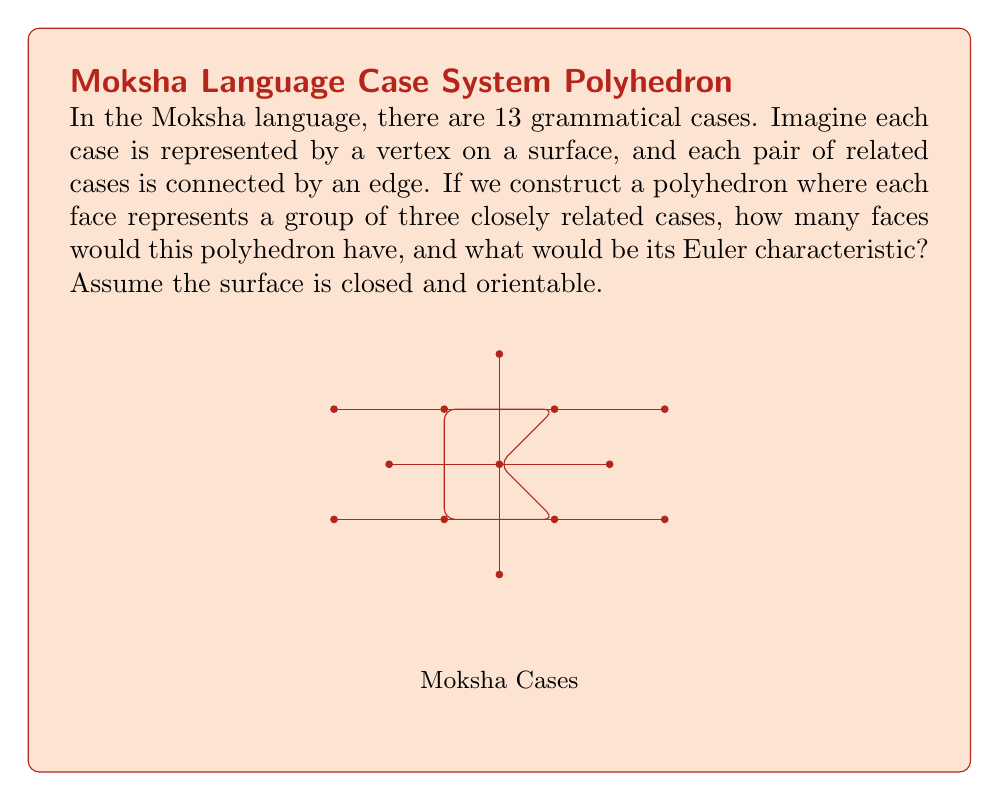What is the answer to this math problem? Let's approach this step-by-step:

1) We know that there are 13 vertices, representing the 13 grammatical cases in Moksha.

2) To calculate the number of faces and the Euler characteristic, we need to determine the number of edges. Let's assume that each vertex is connected to 4 other vertices on average (this is an assumption based on the typical connectivity in linguistic relationships).

3) The number of edges (E) would then be:
   $$ E = \frac{13 \times 4}{2} = 26 $$
   (We divide by 2 to avoid counting each edge twice)

4) Now, to find the number of faces (F), we can use the Euler characteristic formula:
   $$ \chi = V - E + F $$
   Where $\chi$ is the Euler characteristic, V is the number of vertices, E is the number of edges, and F is the number of faces.

5) For a closed, orientable surface, the Euler characteristic is related to the genus g by:
   $$ \chi = 2 - 2g $$

6) Assuming our surface is topologically equivalent to a sphere (g = 0), we have:
   $$ \chi = 2 $$

7) Substituting into the Euler characteristic formula:
   $$ 2 = 13 - 26 + F $$

8) Solving for F:
   $$ F = 2 - 13 + 26 = 15 $$

Therefore, the polyhedron would have 15 faces.

The Euler characteristic, as we determined, is 2.
Answer: 15 faces; Euler characteristic = 2 